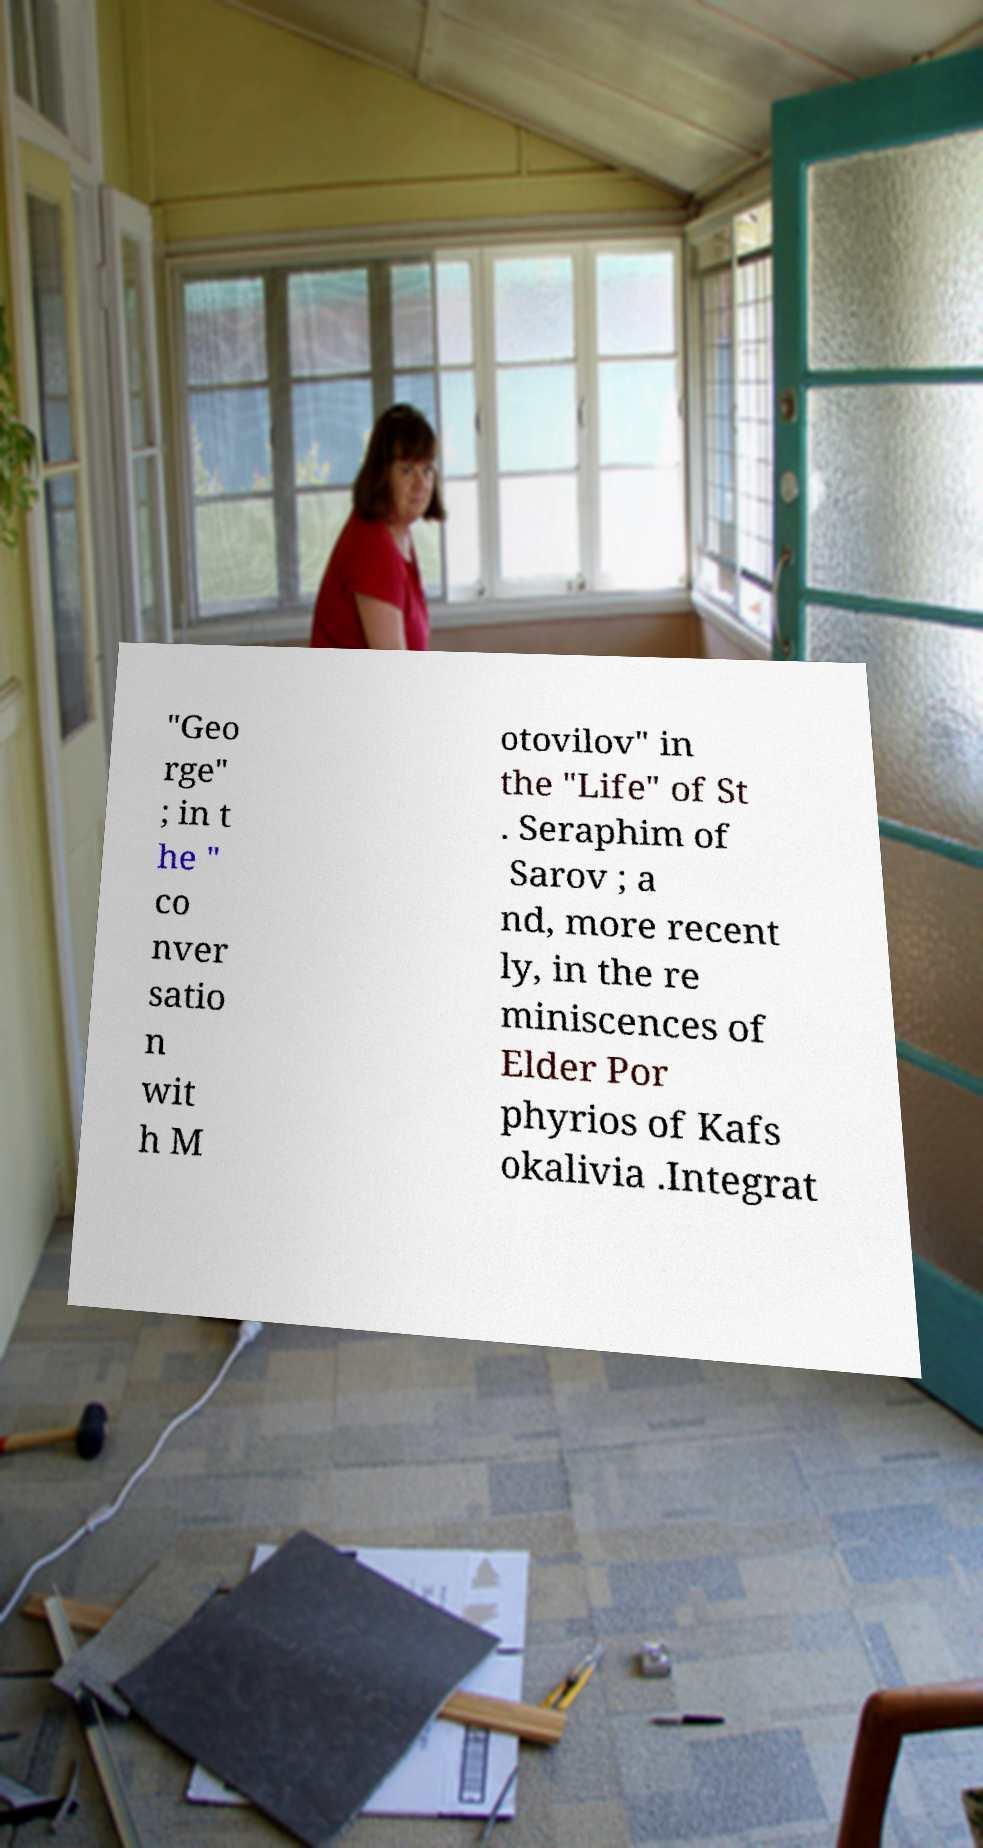Can you read and provide the text displayed in the image?This photo seems to have some interesting text. Can you extract and type it out for me? "Geo rge" ; in t he " co nver satio n wit h M otovilov" in the "Life" of St . Seraphim of Sarov ; a nd, more recent ly, in the re miniscences of Elder Por phyrios of Kafs okalivia .Integrat 